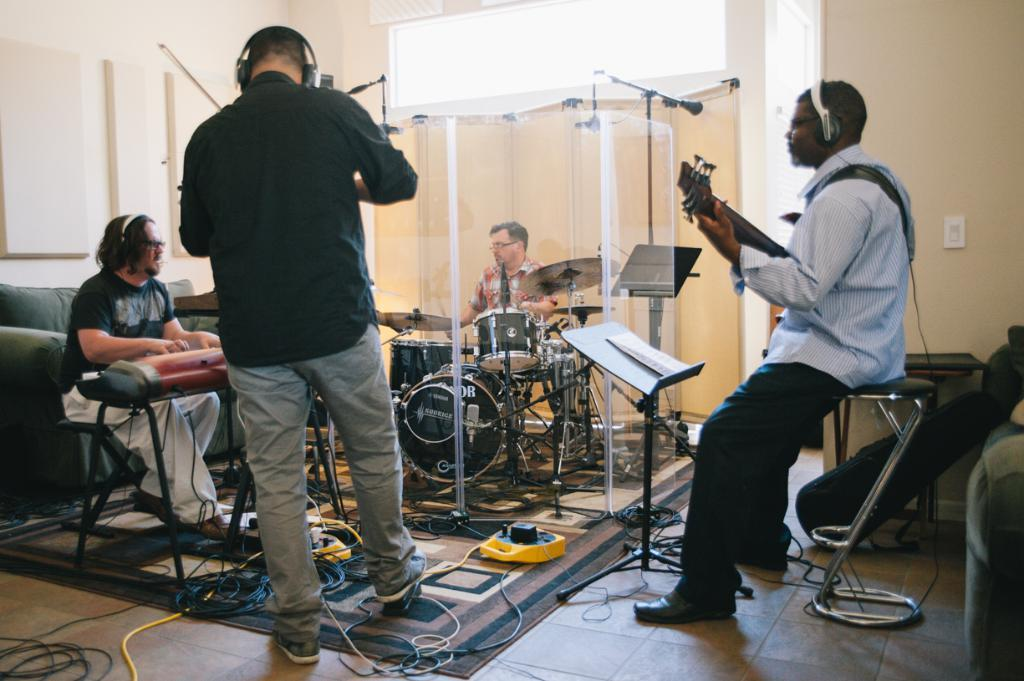How many musicians are present in the image? There are four musicians in the image. What are the positions of the musicians in relation to each other? Three musicians are seated on chairs, and one person is in the middle of the image. What can be seen on the floor in the image? There are wires on the floor in the image. How many fans can be seen in the image? There are no fans visible in the image. What color are the eyes of the person in the middle of the image? The image does not show the eyes of the person in the middle, so we cannot determine their color. 